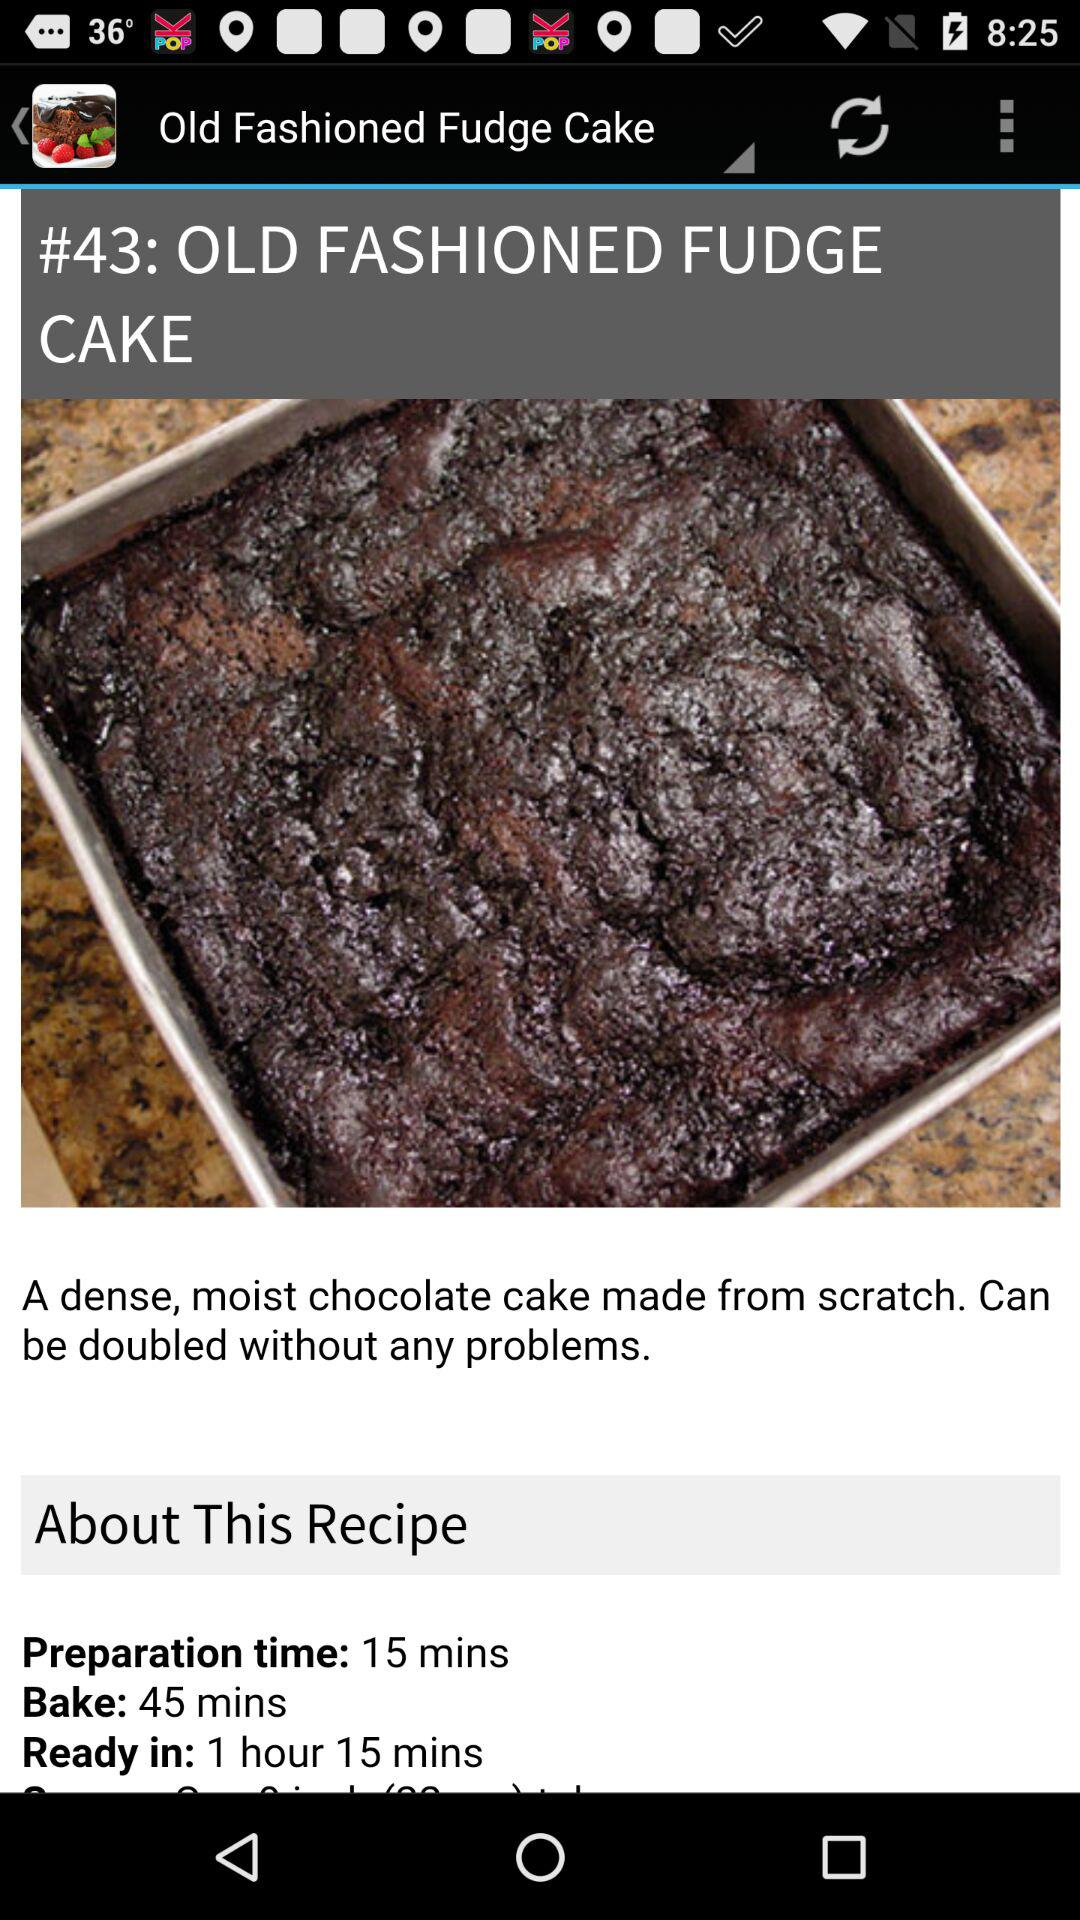How long does it take to make an "OLD FASHIONED FUDGE CAKE"? It takes 1 hour and 15 minutes to make an "OLD FASHIONED FUDGE CAKE". 